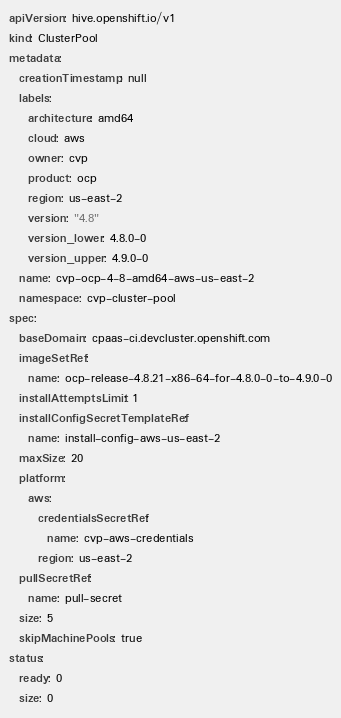Convert code to text. <code><loc_0><loc_0><loc_500><loc_500><_YAML_>apiVersion: hive.openshift.io/v1
kind: ClusterPool
metadata:
  creationTimestamp: null
  labels:
    architecture: amd64
    cloud: aws
    owner: cvp
    product: ocp
    region: us-east-2
    version: "4.8"
    version_lower: 4.8.0-0
    version_upper: 4.9.0-0
  name: cvp-ocp-4-8-amd64-aws-us-east-2
  namespace: cvp-cluster-pool
spec:
  baseDomain: cpaas-ci.devcluster.openshift.com
  imageSetRef:
    name: ocp-release-4.8.21-x86-64-for-4.8.0-0-to-4.9.0-0
  installAttemptsLimit: 1
  installConfigSecretTemplateRef:
    name: install-config-aws-us-east-2
  maxSize: 20
  platform:
    aws:
      credentialsSecretRef:
        name: cvp-aws-credentials
      region: us-east-2
  pullSecretRef:
    name: pull-secret
  size: 5
  skipMachinePools: true
status:
  ready: 0
  size: 0
</code> 